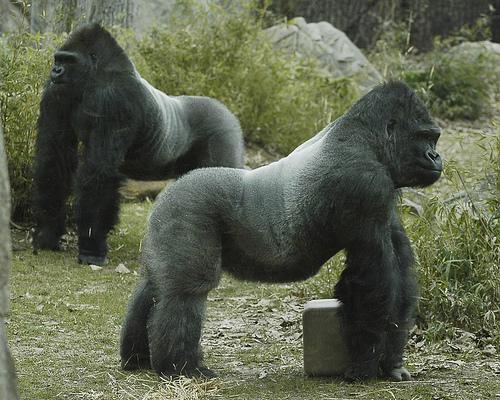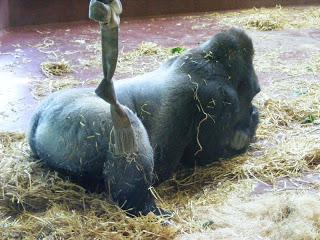The first image is the image on the left, the second image is the image on the right. Examine the images to the left and right. Is the description "The ape in the image on the left is baring its teeth." accurate? Answer yes or no. No. The first image is the image on the left, the second image is the image on the right. Examine the images to the left and right. Is the description "One image shows one ape, which is in a rear-facing on-all-fours pose, and the other image shows a gorilla baring its fangs." accurate? Answer yes or no. No. 